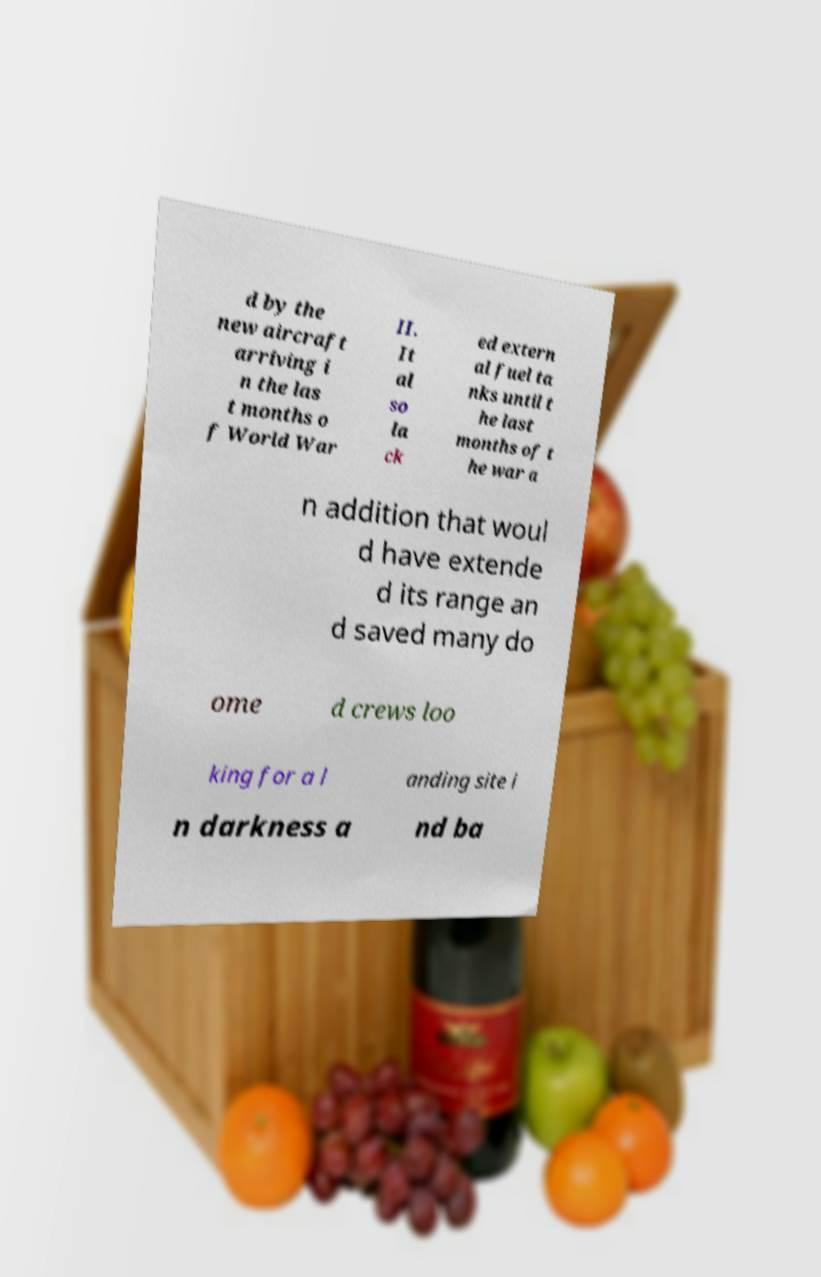Please identify and transcribe the text found in this image. d by the new aircraft arriving i n the las t months o f World War II. It al so la ck ed extern al fuel ta nks until t he last months of t he war a n addition that woul d have extende d its range an d saved many do ome d crews loo king for a l anding site i n darkness a nd ba 